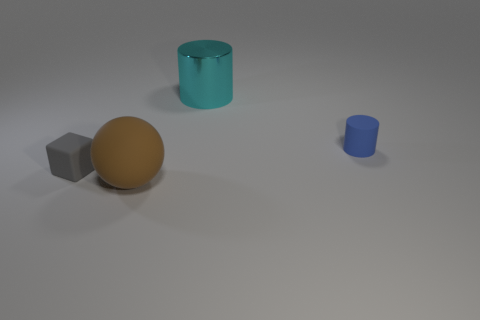What is the relative size of the objects visible in the image? The objects in the image vary in size. The gray cube is the smallest, followed by the blue cylinder. The teal cylinder is larger than both, and the orange sphere is the largest with respect to the other objects. 